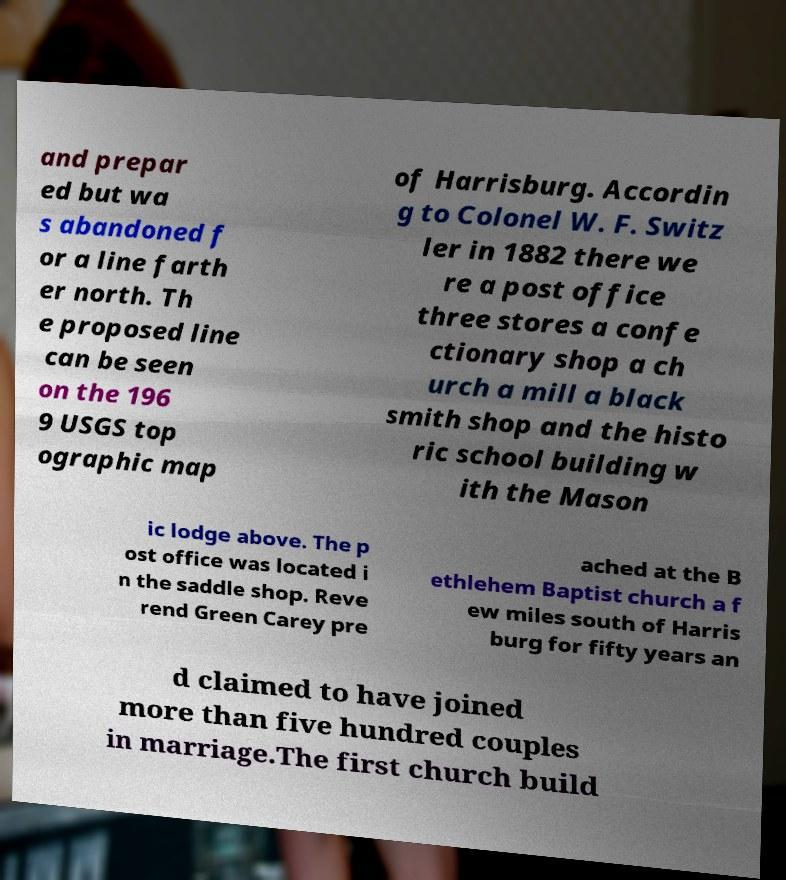Please identify and transcribe the text found in this image. and prepar ed but wa s abandoned f or a line farth er north. Th e proposed line can be seen on the 196 9 USGS top ographic map of Harrisburg. Accordin g to Colonel W. F. Switz ler in 1882 there we re a post office three stores a confe ctionary shop a ch urch a mill a black smith shop and the histo ric school building w ith the Mason ic lodge above. The p ost office was located i n the saddle shop. Reve rend Green Carey pre ached at the B ethlehem Baptist church a f ew miles south of Harris burg for fifty years an d claimed to have joined more than five hundred couples in marriage.The first church build 